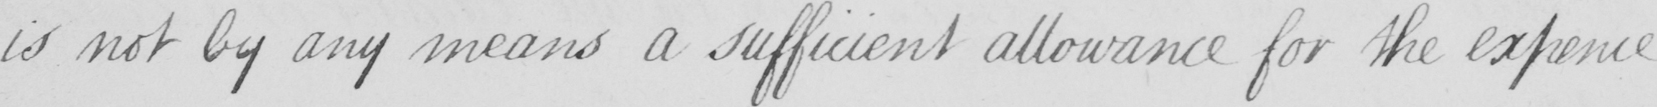What is written in this line of handwriting? is not by any means a sufficient allowance for the expence 